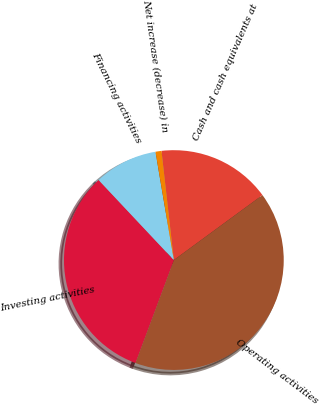Convert chart to OTSL. <chart><loc_0><loc_0><loc_500><loc_500><pie_chart><fcel>Cash and cash equivalents at<fcel>Operating activities<fcel>Investing activities<fcel>Financing activities<fcel>Net increase (decrease) in<nl><fcel>16.73%<fcel>40.76%<fcel>32.31%<fcel>9.33%<fcel>0.88%<nl></chart> 